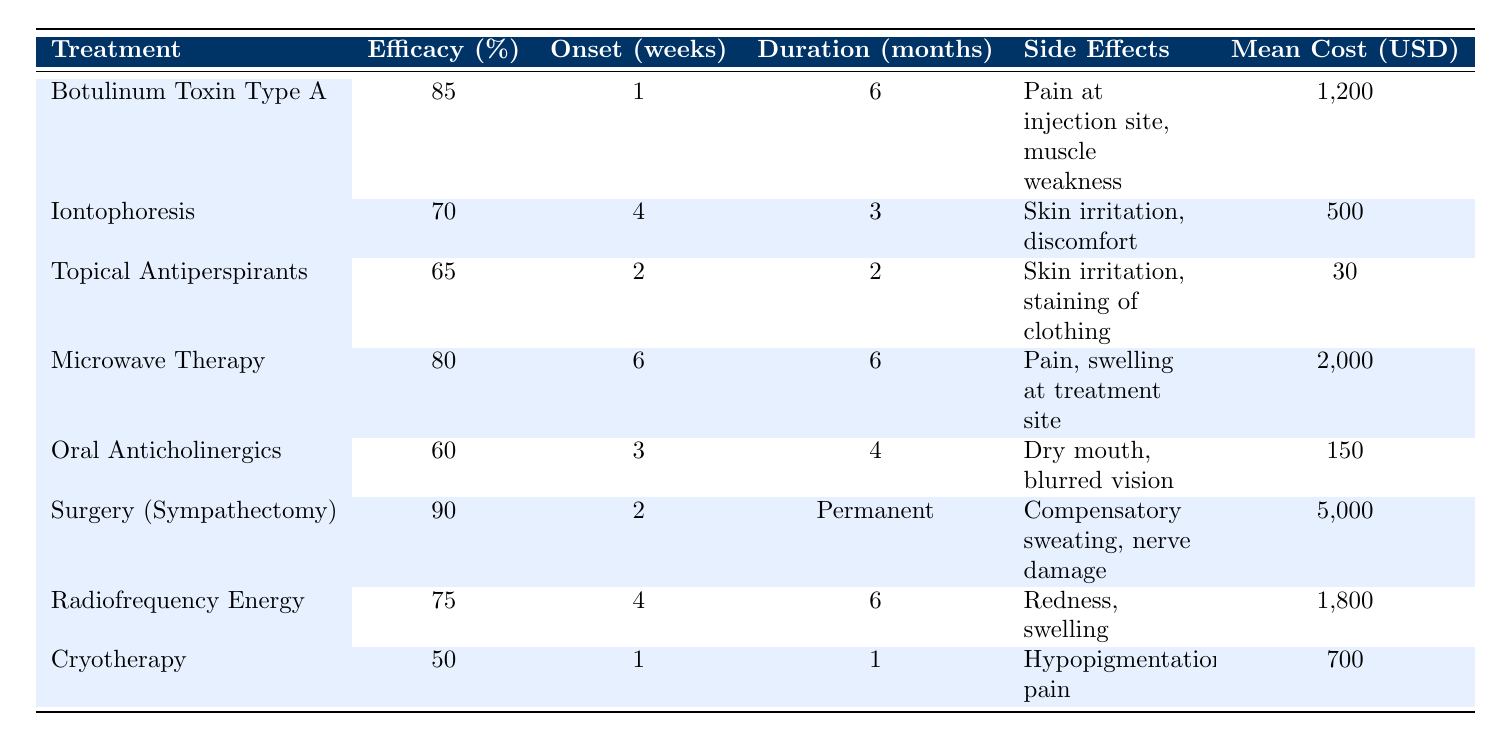What is the efficacy percentage of Botulinum Toxin Type A? The table shows that the efficacy percentage for Botulinum Toxin Type A is listed in the second column next to its name. The value is 85%.
Answer: 85% How long does it take for the effects of Cryotherapy to onset? According to the table, the onset time for Cryotherapy is provided in the third column. It states the onset time is 1 week.
Answer: 1 week Which treatment has the lowest mean cost? The mean cost is listed in the last column. By comparing all the treatment costs, Topical Antiperspirants (Aluminum Chloride) has the lowest cost at $30.
Answer: $30 What is the average efficacy percentage of the treatments listed? To find the average efficacy, add all the efficacy percentages (85 + 70 + 65 + 80 + 60 + 90 + 75 + 50) = 675. There are 8 treatments, so divide 675 by 8 to get the average: 675/8 = 84.375.
Answer: 84.375% Is the duration of effects for Surgery (Sympathectomy) permanent? The table indicates that the duration for Surgery (Sympathectomy) is "Permanent," which answers the question affirmatively.
Answer: Yes What is the total mean cost of the top three treatments by efficacy? The top three treatments by efficacy are Surgery (Sympathectomy, 90%), Botulinum Toxin Type A (85%), and Microwave Therapy (80%). Their respective costs are $5000, $1200, and $2000. Therefore, the total cost is $5000 + $1200 + $2000 = $8200.
Answer: $8200 Which treatment takes the longest for onset effects, and how long is it? By reviewing the onset times from the table, Microwave Therapy takes the longest with an onset time of 6 weeks.
Answer: Microwave Therapy, 6 weeks What is the difference in efficacy percentage between Iontophoresis and Oral Anticholinergics? The efficacy percentage for Iontophoresis is 70%, and for Oral Anticholinergics, it is 60%. The difference is calculated by subtracting: 70 - 60 = 10.
Answer: 10% If a patient opts for Radiofrequency Energy Therapy, what side effects should they be aware of? The side effects related to Radiofrequency Energy Therapy are listed in the table, which states they include redness and swelling.
Answer: Redness, swelling Which treatment modalities have side effects that include skin irritation? By analyzing the side effects listed in the table, both Iontophoresis and Topical Antiperspirants (Aluminum Chloride) have "skin irritation" among their side effects.
Answer: Iontophoresis, Topical Antiperspirants What is the average duration for the treatments that last more than 3 months? Only Botulinum Toxin Type A (6 months), Microwave Therapy (6 months), Surgery (Permanent), and Radiofrequency Energy Therapy (6 months) last more than 3 months. First, convert "Permanent" to a numerical value: assuming it as a maximum of 12 months. Thus their total duration is 6 + 6 + 12 + 6 = 30 months. Then, divide by the total treatments (4). Average = 30 / 4 = 7.5 months.
Answer: 7.5 months 